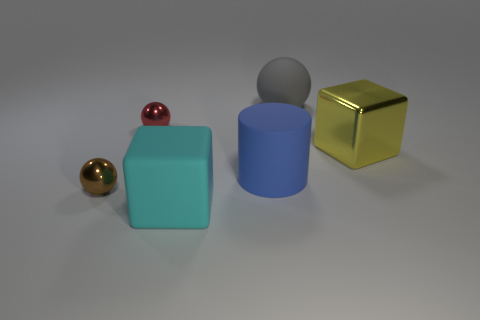Which objects in the scene could float in water? Based on the visuals, it's likely that the small spheres could float due to their size and potential lightweight material. The cube shapes might also float if they are made of a low-density material such as plastic; however, if they are metallic or made of another dense material, they would sink. 